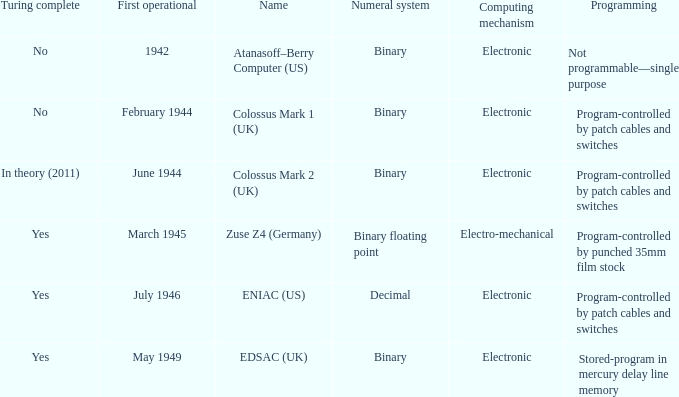What's the computing mechanbeingm with name being atanasoff–berry computer (us) Electronic. 